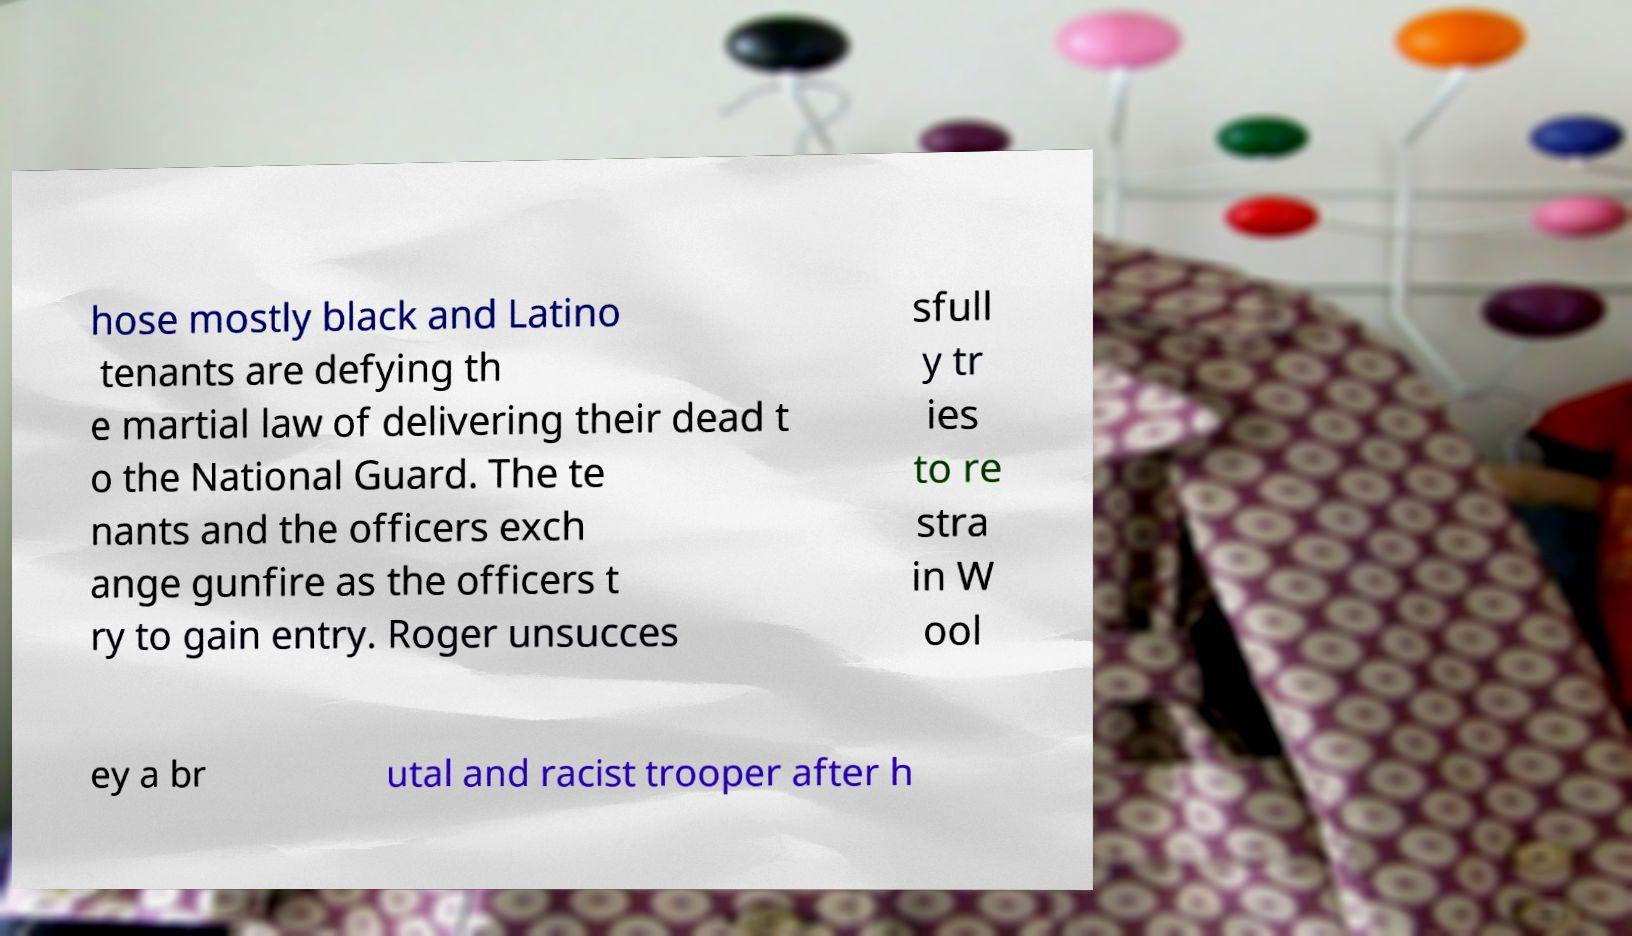What messages or text are displayed in this image? I need them in a readable, typed format. hose mostly black and Latino tenants are defying th e martial law of delivering their dead t o the National Guard. The te nants and the officers exch ange gunfire as the officers t ry to gain entry. Roger unsucces sfull y tr ies to re stra in W ool ey a br utal and racist trooper after h 